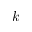<formula> <loc_0><loc_0><loc_500><loc_500>k</formula> 